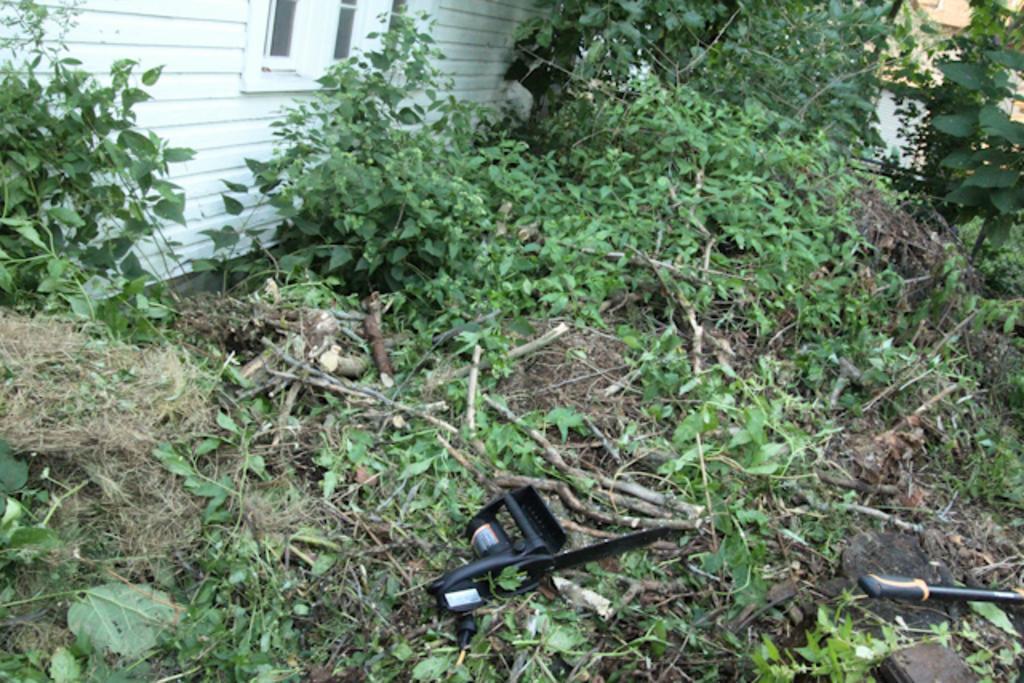Can you describe this image briefly? In this image at the top there is the wall, window, there are some plants, creeps, grass, sticks, some other objects visible in the middle. 